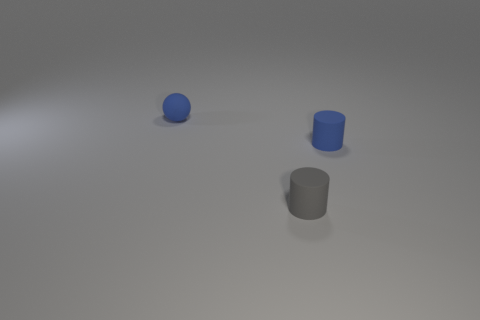Does the small ball have the same material as the small blue cylinder?
Offer a terse response. Yes. Is the number of blue things that are behind the tiny blue sphere the same as the number of tiny blue objects on the left side of the tiny gray rubber cylinder?
Provide a succinct answer. No. There is a blue thing that is behind the tiny blue rubber thing to the right of the blue rubber ball; are there any small gray matte cylinders that are on the left side of it?
Your answer should be very brief. No. Does the matte ball have the same size as the gray matte thing?
Give a very brief answer. Yes. There is a small matte thing that is on the right side of the rubber cylinder left of the small blue thing that is right of the blue ball; what is its color?
Provide a succinct answer. Blue. What number of small cylinders have the same color as the tiny sphere?
Give a very brief answer. 1. What number of small objects are blue cylinders or rubber spheres?
Give a very brief answer. 2. Is there a big blue thing of the same shape as the tiny gray thing?
Provide a succinct answer. No. The object behind the small matte object on the right side of the gray rubber cylinder is what color?
Your answer should be very brief. Blue. What color is the other matte cylinder that is the same size as the gray rubber cylinder?
Keep it short and to the point. Blue. 